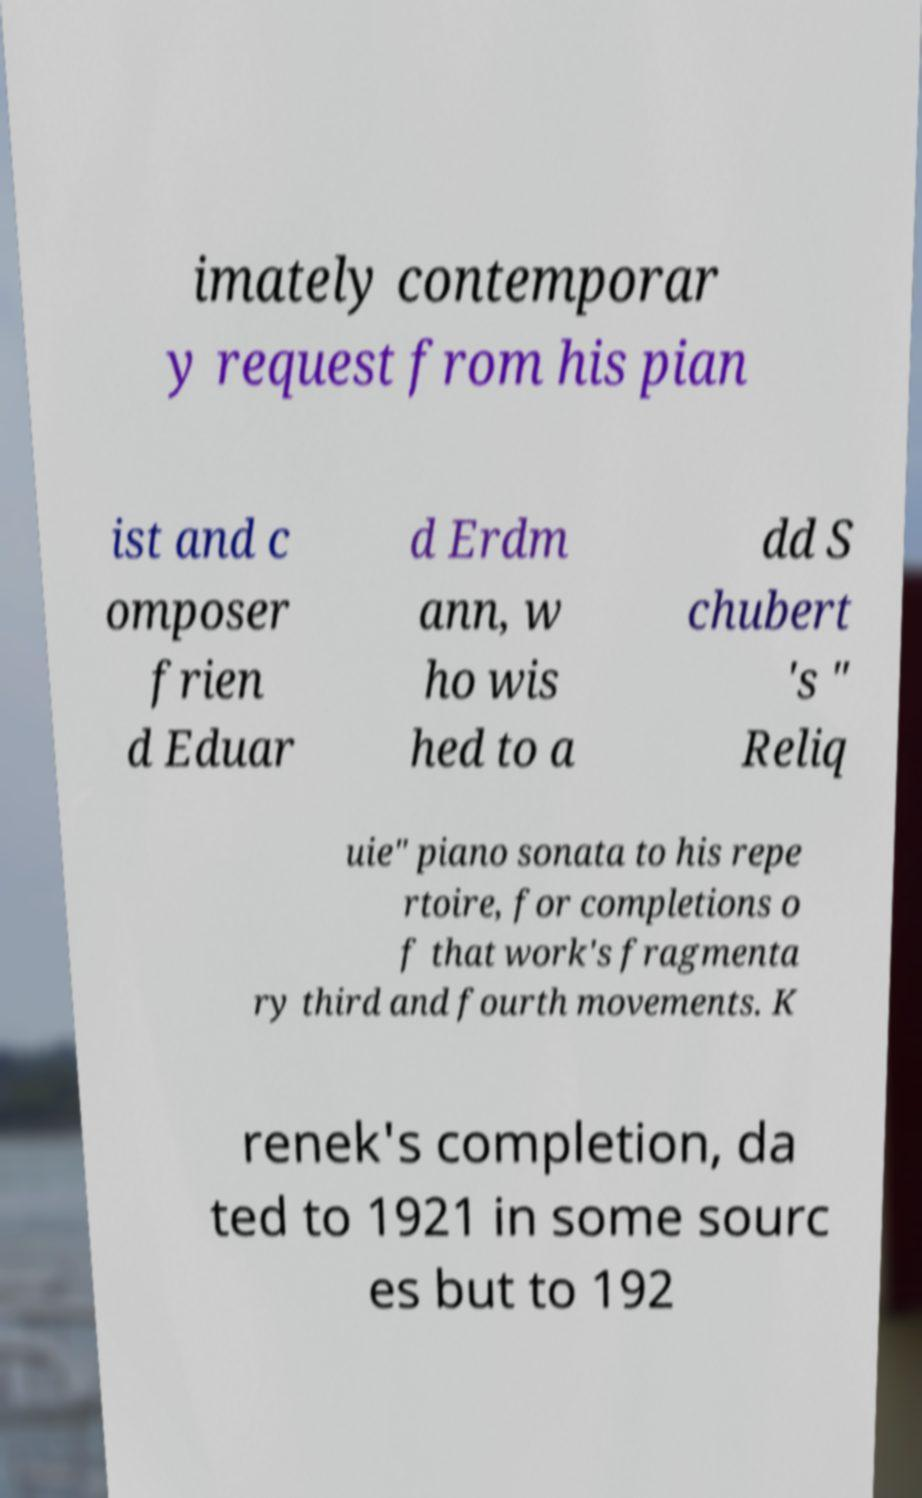Could you extract and type out the text from this image? imately contemporar y request from his pian ist and c omposer frien d Eduar d Erdm ann, w ho wis hed to a dd S chubert 's " Reliq uie" piano sonata to his repe rtoire, for completions o f that work's fragmenta ry third and fourth movements. K renek's completion, da ted to 1921 in some sourc es but to 192 